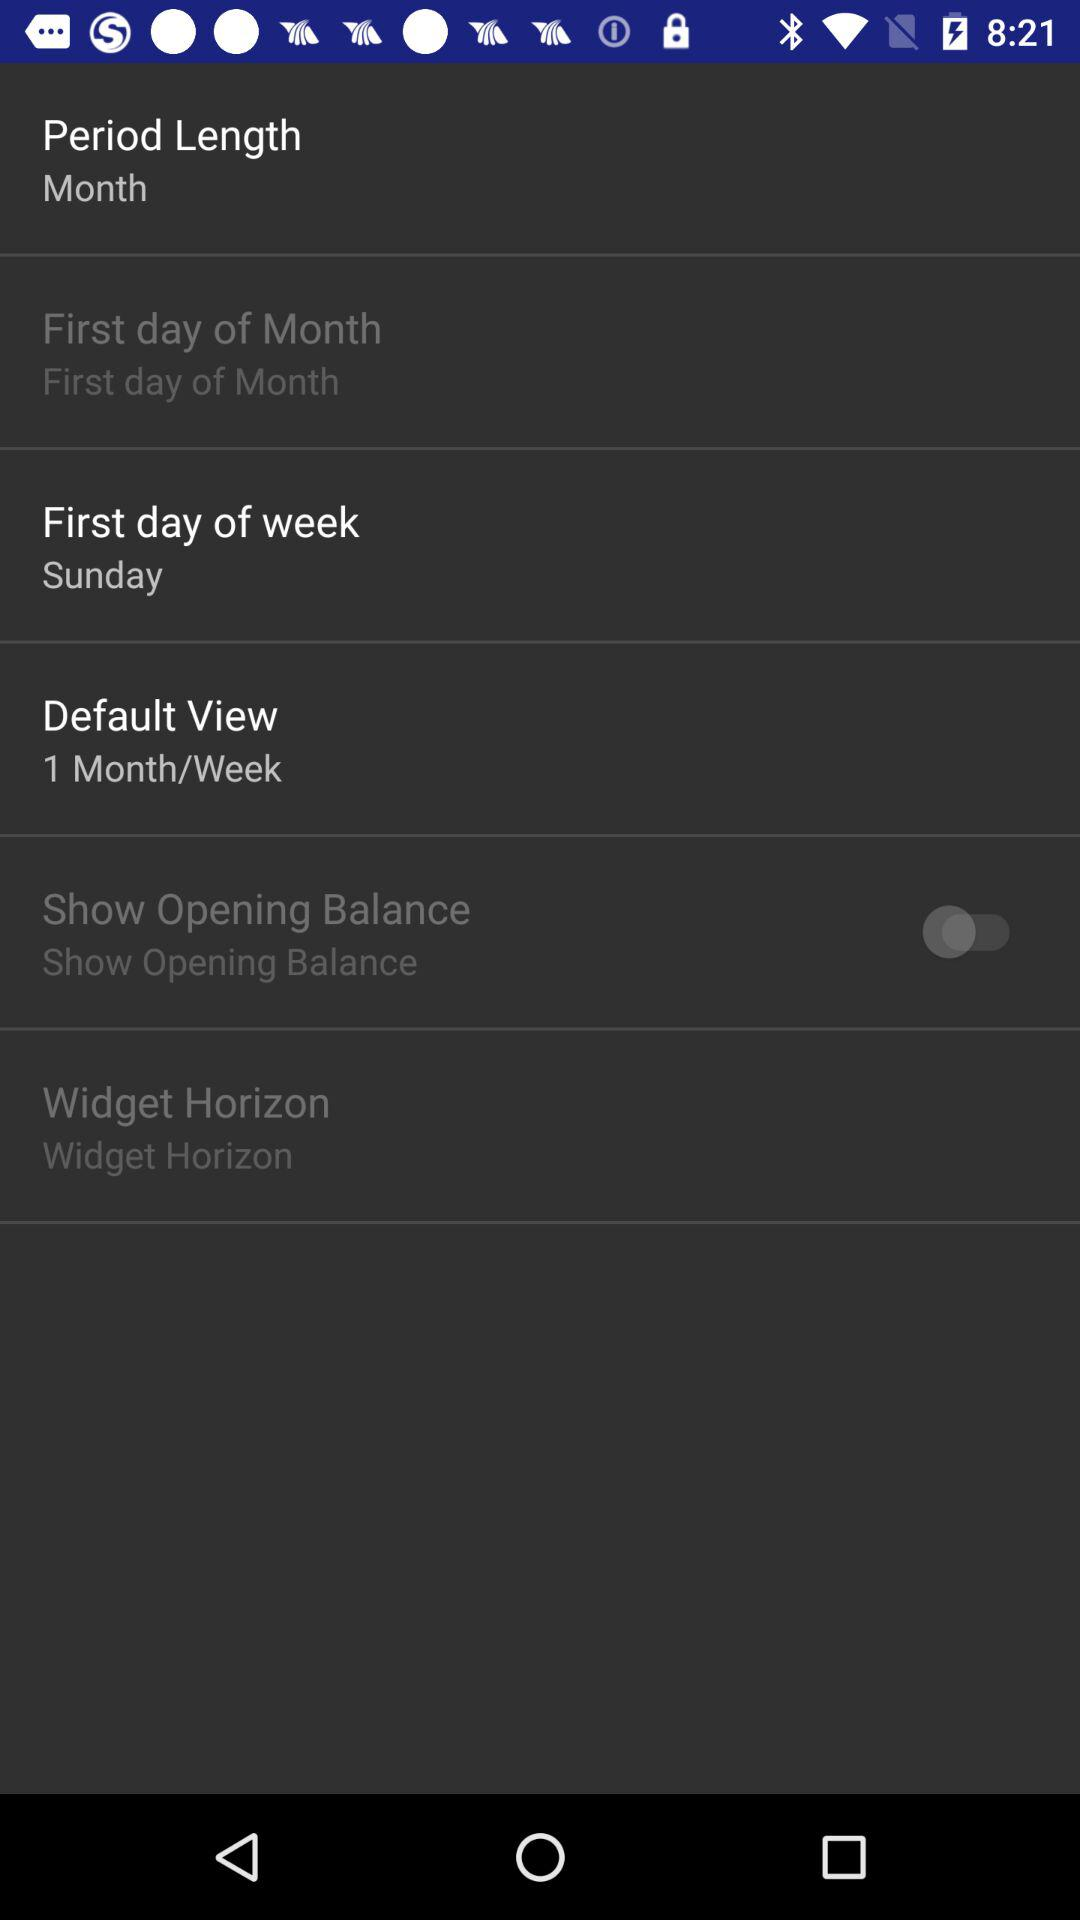Which day is the first day of week? The first day of week is Sunday. 